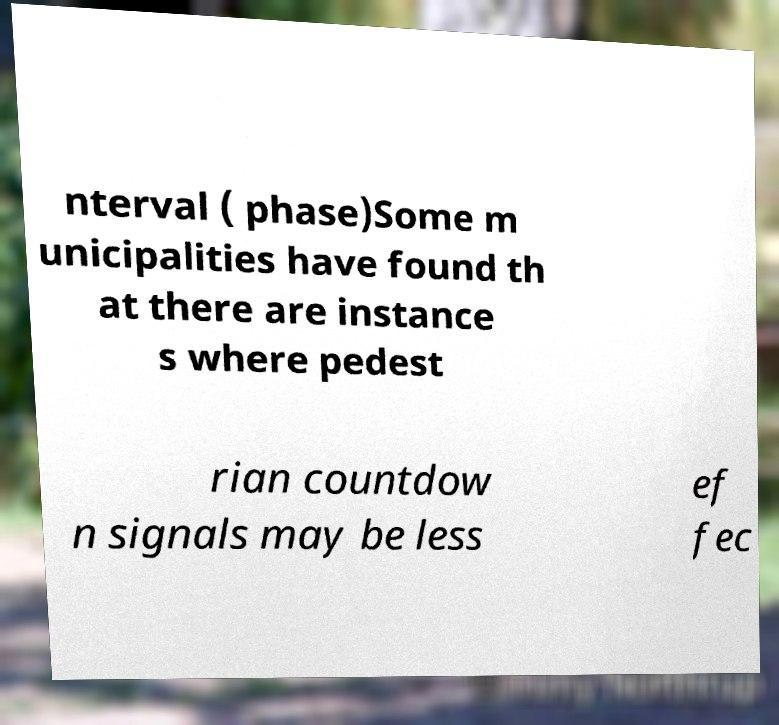Please read and relay the text visible in this image. What does it say? nterval ( phase)Some m unicipalities have found th at there are instance s where pedest rian countdow n signals may be less ef fec 